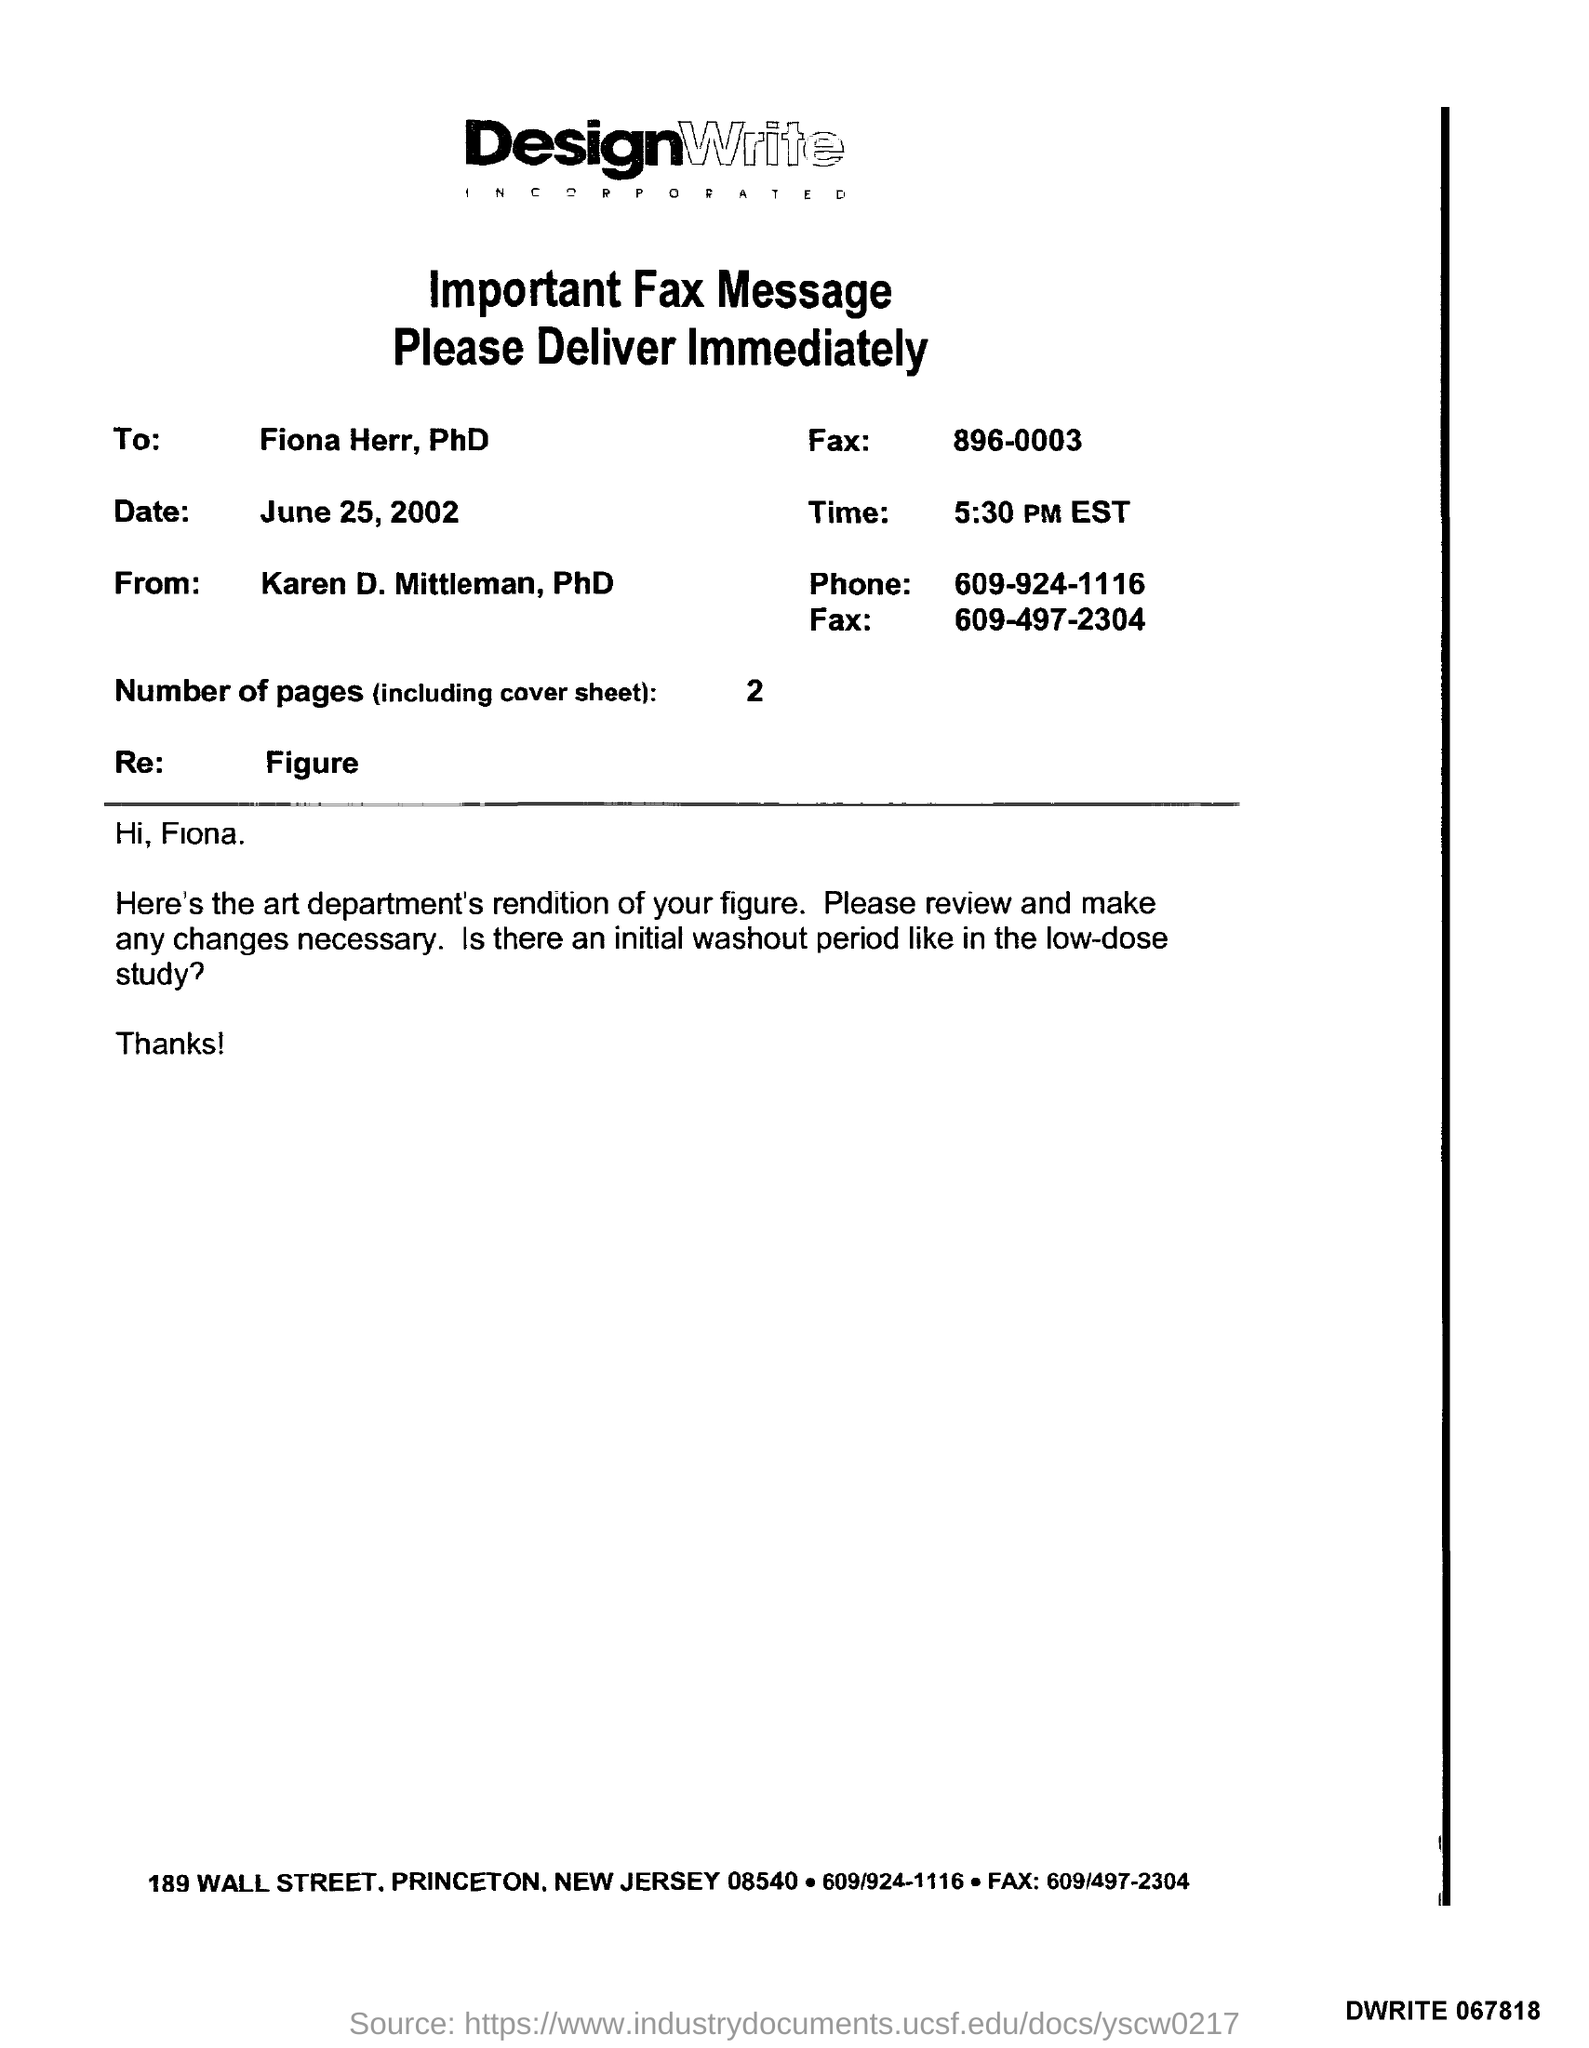Mention a couple of crucial points in this snapshot. At 5:30 PM EST, the time is being given. There are two pages, including the cover sheet. The fax was dated June 25, 2002. The fax is from Karen D. Mittleman, PhD. The fax is addressed to Fiona Herr. 